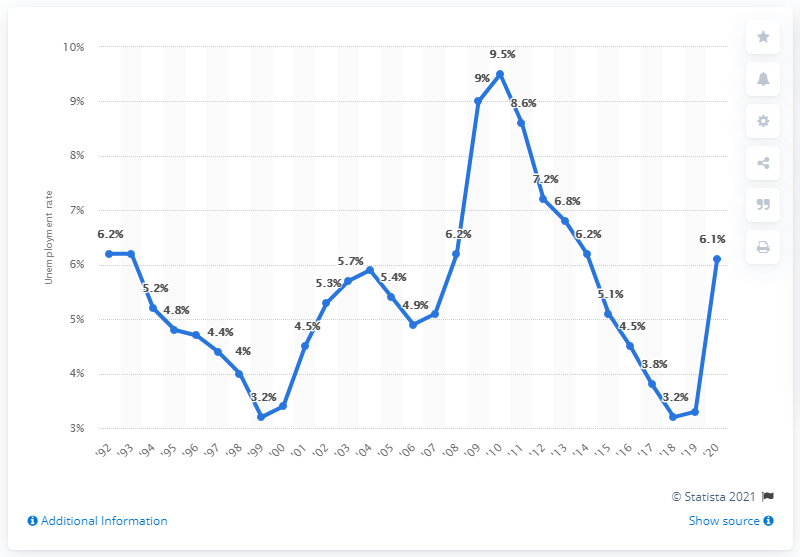Give some essential details in this illustration. In 2010, the unemployment rate in the state of Missouri was 3.3%. In 2010, the highest unemployment rate in the state of Missouri was 9.5%. In 2020, the unemployment rate in the state of Missouri was 6.1%. 